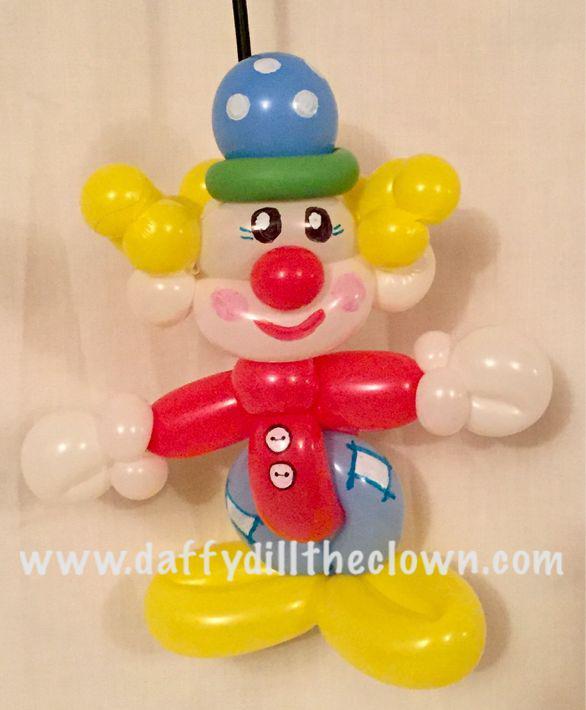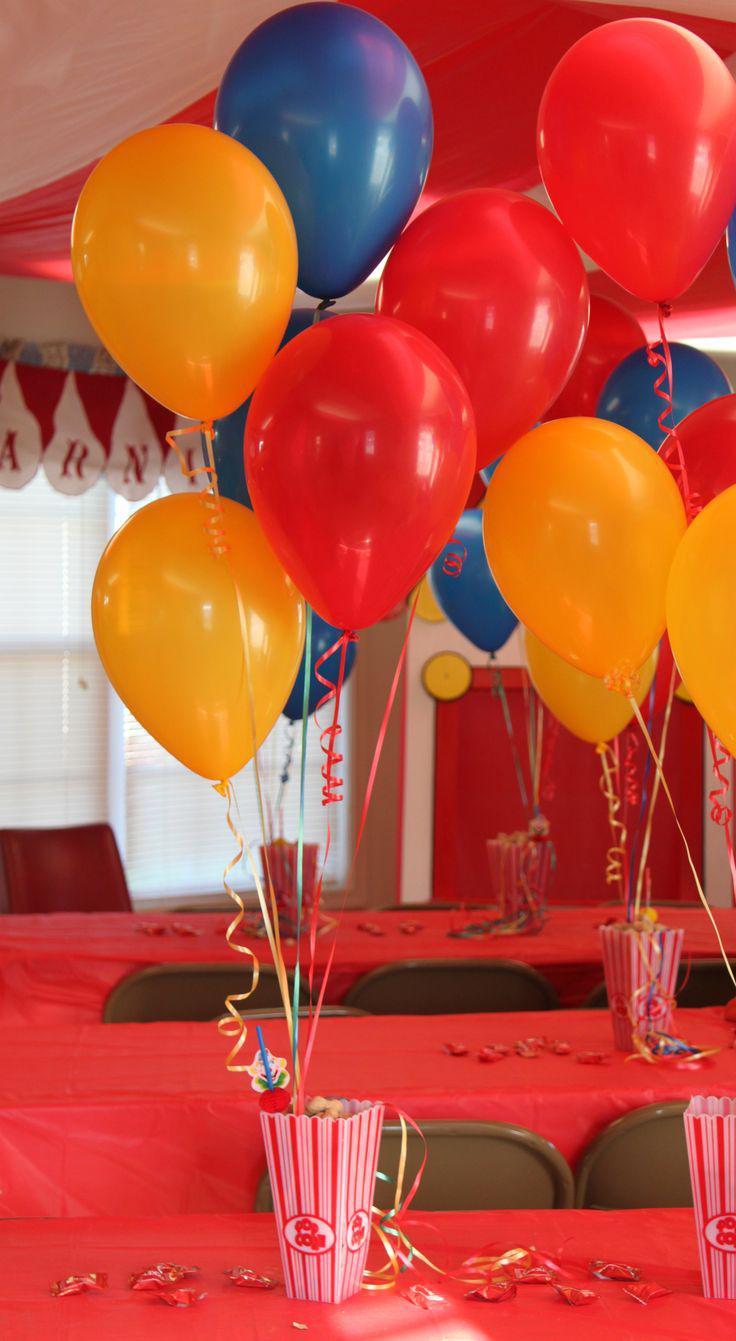The first image is the image on the left, the second image is the image on the right. Examine the images to the left and right. Is the description "One of the images shows a clown wearing a hat." accurate? Answer yes or no. Yes. 